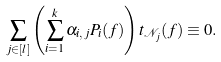Convert formula to latex. <formula><loc_0><loc_0><loc_500><loc_500>\sum _ { j \in [ l ] } \left ( \sum _ { i = 1 } ^ { k } \alpha _ { i , j } P _ { i } ( f ) \right ) t _ { \mathcal { N } _ { j } } ( f ) \equiv 0 .</formula> 